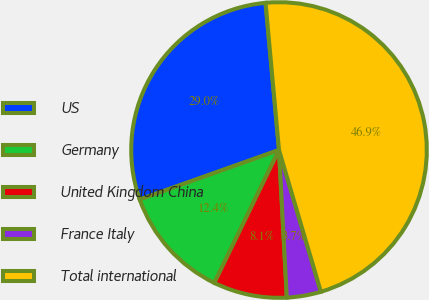<chart> <loc_0><loc_0><loc_500><loc_500><pie_chart><fcel>US<fcel>Germany<fcel>United Kingdom China<fcel>France Italy<fcel>Total international<nl><fcel>28.98%<fcel>12.36%<fcel>8.05%<fcel>3.73%<fcel>46.88%<nl></chart> 